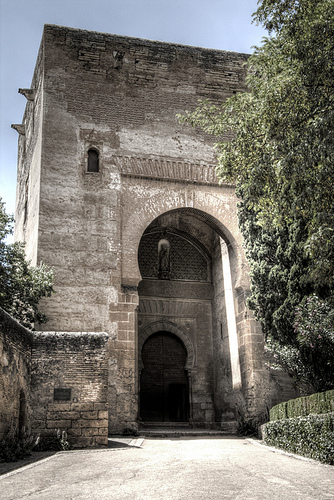<image>
Is the door next to the building? No. The door is not positioned next to the building. They are located in different areas of the scene. Where is the door in relation to the sidewalk? Is it on the sidewalk? No. The door is not positioned on the sidewalk. They may be near each other, but the door is not supported by or resting on top of the sidewalk. 